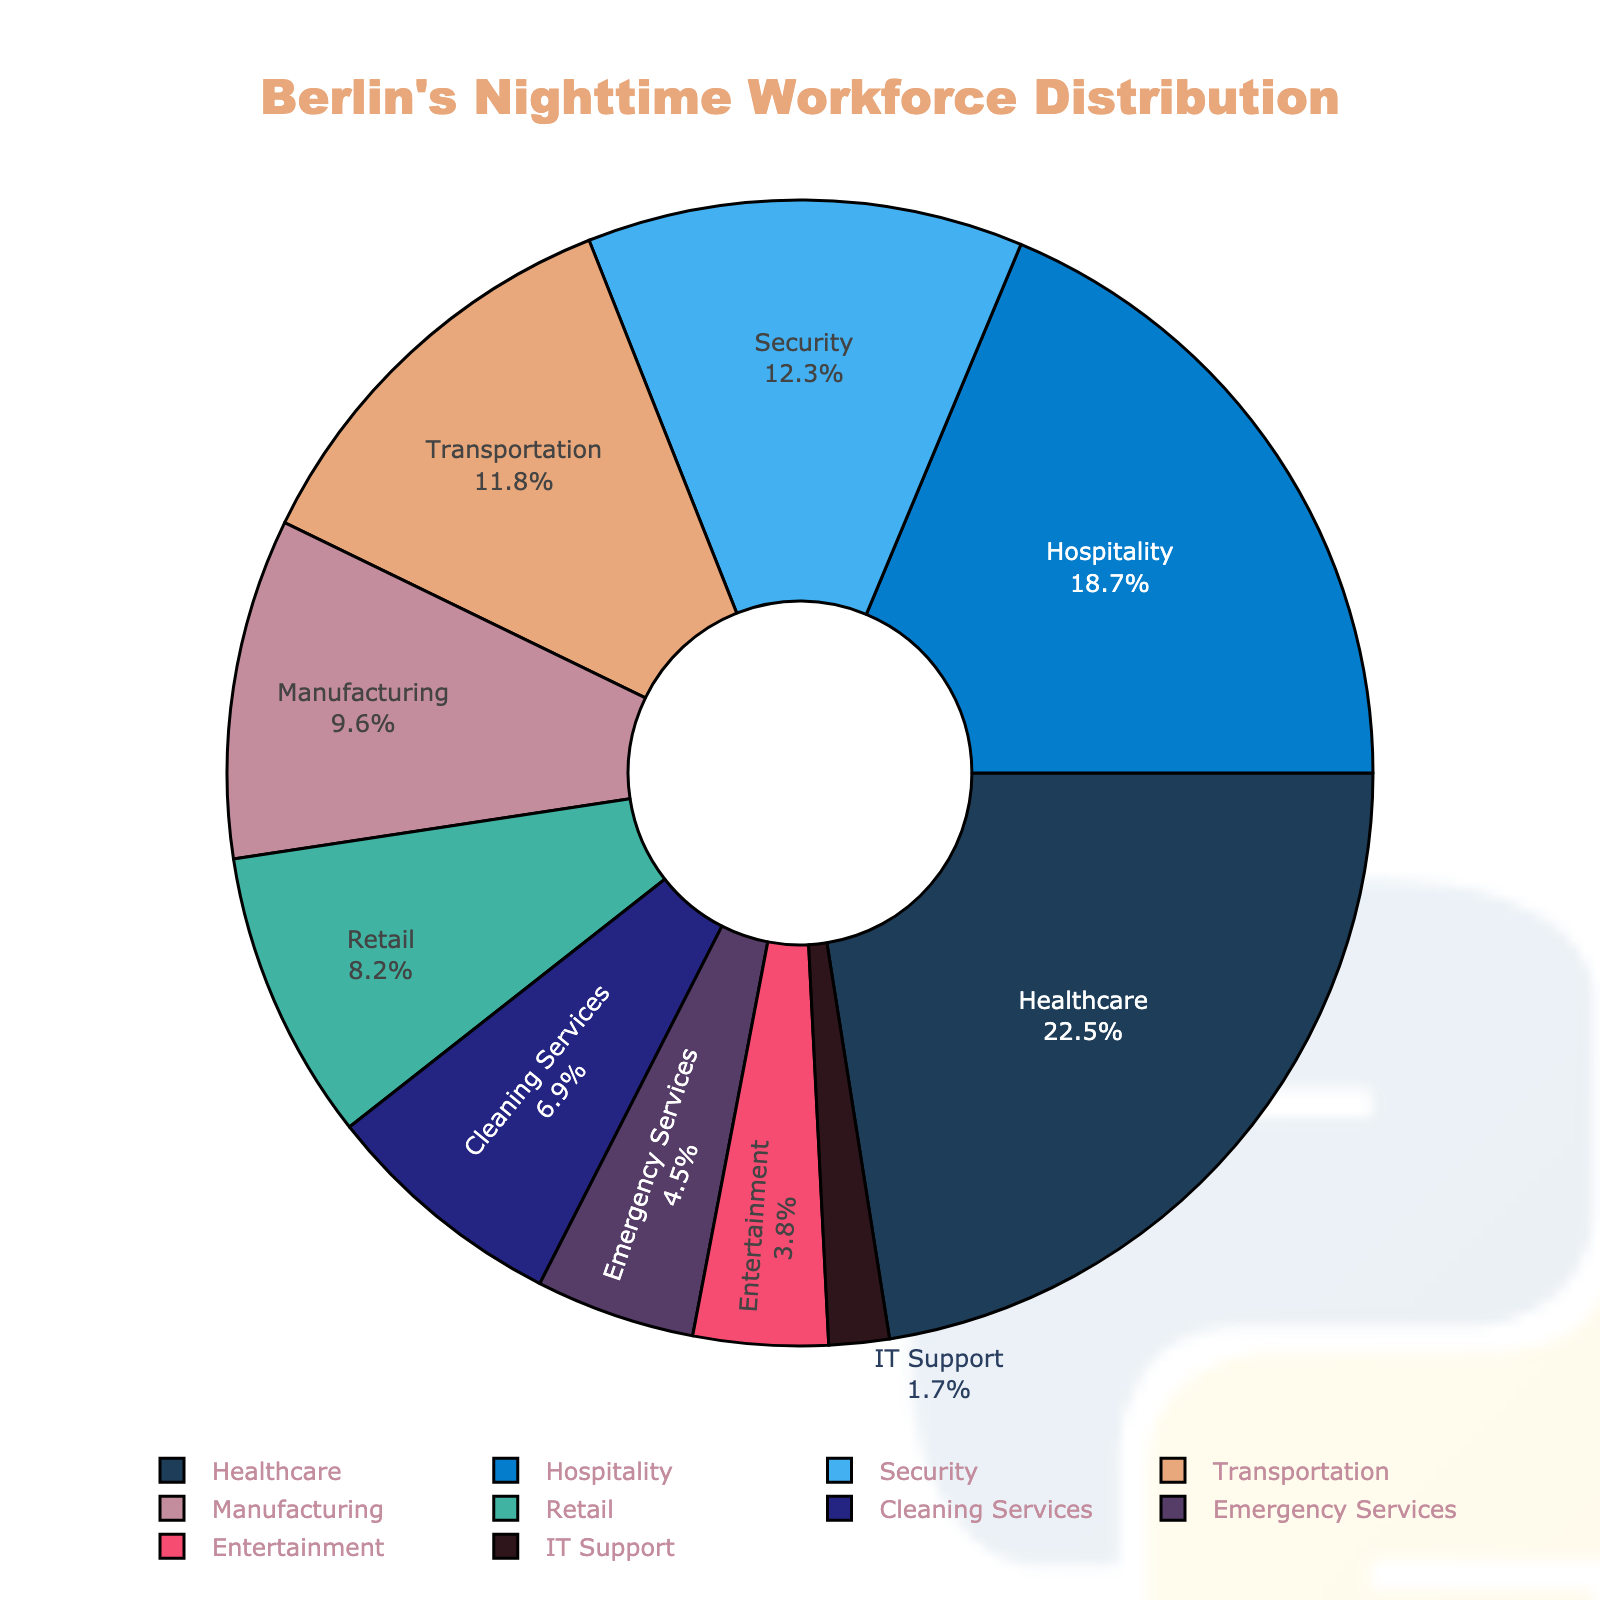What is the largest segment in the pie chart? The largest segment has the highest percentage. In this chart, "Healthcare" has the highest value at 22.5%.
Answer: Healthcare Which industry has the smallest percentage of Berlin's nighttime workforce? The smallest segment in the chart is the one with the lowest percentage. In this chart, "IT Support" has the lowest value at 1.7%.
Answer: IT Support What is the total percentage of the top three industries combined? The top three industries are Healthcare (22.5%), Hospitality (18.7%), and Security (12.3%). Sum these values: 22.5 + 18.7 + 12.3 = 53.5%.
Answer: 53.5% Which industries have a percentage greater than 10%? Check each segment in the pie chart to see which ones exceed 10%. Industries with percentages greater than 10% are Healthcare (22.5%), Hospitality (18.7%), Security (12.3%), and Transportation (11.8%).
Answer: Healthcare, Hospitality, Security, Transportation How much more is the percentage of Healthcare workers compared to IT Support workers? Subtract the percentage of IT Support from Healthcare: 22.5% - 1.7% = 20.8%.
Answer: 20.8% What is the combined percentage of industries with less than 5% representation? Identify segments with percentages less than 5%: Emergency Services (4.5%), Entertainment (3.8%), IT Support (1.7%). Sum these values: 4.5 + 3.8 + 1.7 = 10%.
Answer: 10% Compare the percentage of Manufacturing workers to Retail workers. Look at the percentages of Manufacturing (9.6%) and Retail (8.2%). Manufacturing has a higher percentage than Retail.
Answer: Manufacturing > Retail What is the total percentage of Cleaning Services and Retail industries combined? Add the percentages for Cleaning Services (6.9%) and Retail (8.2%): 6.9 + 8.2 = 15.1%.
Answer: 15.1% Describe the color associated with the Transportation industry. Identify the segment for Transportation, which is represented in a specific color inspired by Berlin's nighttime cityscape. The color associated with Transportation is light blue.
Answer: light blue Which industry has a percentage closest to 10%? Look for the segment with a percentage closest to 10%. The closest segment is Manufacturing with 9.6%.
Answer: Manufacturing 